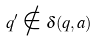<formula> <loc_0><loc_0><loc_500><loc_500>q ^ { \prime } \notin \delta ( q , a )</formula> 